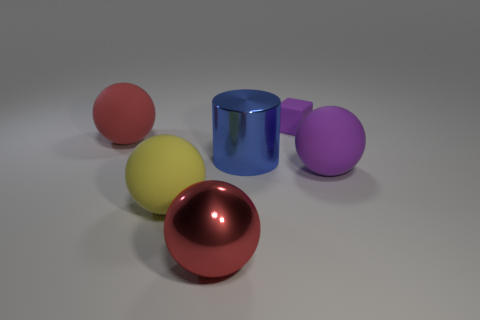What number of purple things are tiny matte things or tiny cylinders?
Your response must be concise. 1. Is the material of the blue cylinder the same as the red sphere in front of the yellow ball?
Offer a very short reply. Yes. Is the number of big blue metallic cylinders that are right of the cube the same as the number of big rubber things that are in front of the purple ball?
Ensure brevity in your answer.  No. There is a cylinder; is its size the same as the purple rubber object that is in front of the large blue metal cylinder?
Provide a short and direct response. Yes. Are there more blue things in front of the large red matte ball than big gray metallic cubes?
Offer a very short reply. Yes. What number of purple rubber objects have the same size as the yellow matte object?
Your answer should be compact. 1. There is a shiny object right of the large shiny ball; is it the same size as the purple rubber thing behind the large blue shiny cylinder?
Make the answer very short. No. Are there more red matte objects left of the purple matte block than purple matte spheres that are to the left of the shiny cylinder?
Your answer should be very brief. Yes. What number of other small objects have the same shape as the tiny thing?
Keep it short and to the point. 0. There is a blue object that is the same size as the yellow object; what is it made of?
Provide a short and direct response. Metal. 